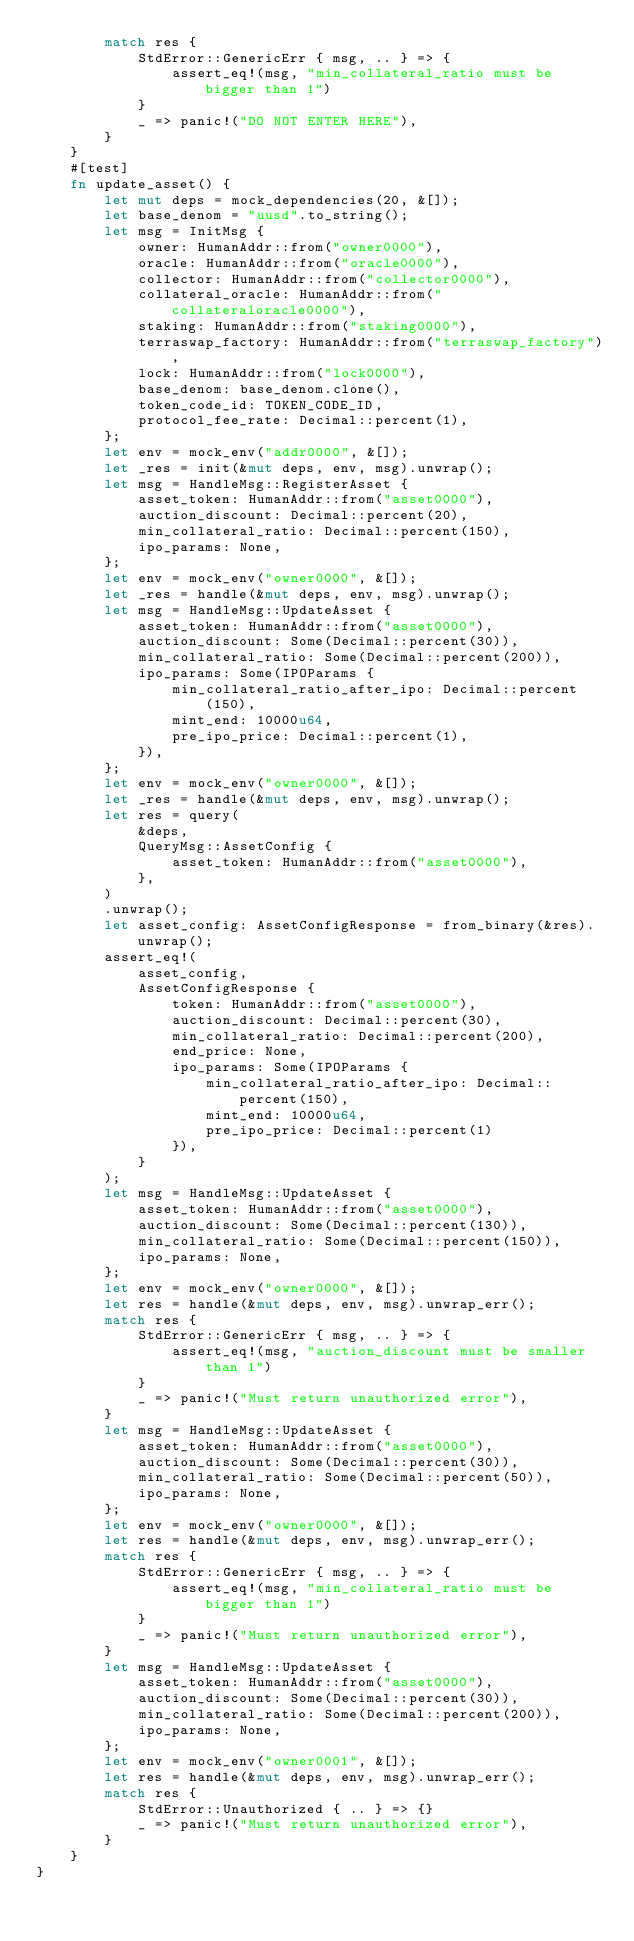<code> <loc_0><loc_0><loc_500><loc_500><_Rust_>        match res {
            StdError::GenericErr { msg, .. } => {
                assert_eq!(msg, "min_collateral_ratio must be bigger than 1")
            }
            _ => panic!("DO NOT ENTER HERE"),
        }
    }
    #[test]
    fn update_asset() {
        let mut deps = mock_dependencies(20, &[]);
        let base_denom = "uusd".to_string();
        let msg = InitMsg {
            owner: HumanAddr::from("owner0000"),
            oracle: HumanAddr::from("oracle0000"),
            collector: HumanAddr::from("collector0000"),
            collateral_oracle: HumanAddr::from("collateraloracle0000"),
            staking: HumanAddr::from("staking0000"),
            terraswap_factory: HumanAddr::from("terraswap_factory"),
            lock: HumanAddr::from("lock0000"),
            base_denom: base_denom.clone(),
            token_code_id: TOKEN_CODE_ID,
            protocol_fee_rate: Decimal::percent(1),
        };
        let env = mock_env("addr0000", &[]);
        let _res = init(&mut deps, env, msg).unwrap();
        let msg = HandleMsg::RegisterAsset {
            asset_token: HumanAddr::from("asset0000"),
            auction_discount: Decimal::percent(20),
            min_collateral_ratio: Decimal::percent(150),
            ipo_params: None,
        };
        let env = mock_env("owner0000", &[]);
        let _res = handle(&mut deps, env, msg).unwrap();
        let msg = HandleMsg::UpdateAsset {
            asset_token: HumanAddr::from("asset0000"),
            auction_discount: Some(Decimal::percent(30)),
            min_collateral_ratio: Some(Decimal::percent(200)),
            ipo_params: Some(IPOParams {
                min_collateral_ratio_after_ipo: Decimal::percent(150),
                mint_end: 10000u64,
                pre_ipo_price: Decimal::percent(1),
            }),
        };
        let env = mock_env("owner0000", &[]);
        let _res = handle(&mut deps, env, msg).unwrap();
        let res = query(
            &deps,
            QueryMsg::AssetConfig {
                asset_token: HumanAddr::from("asset0000"),
            },
        )
        .unwrap();
        let asset_config: AssetConfigResponse = from_binary(&res).unwrap();
        assert_eq!(
            asset_config,
            AssetConfigResponse {
                token: HumanAddr::from("asset0000"),
                auction_discount: Decimal::percent(30),
                min_collateral_ratio: Decimal::percent(200),
                end_price: None,
                ipo_params: Some(IPOParams {
                    min_collateral_ratio_after_ipo: Decimal::percent(150),
                    mint_end: 10000u64,
                    pre_ipo_price: Decimal::percent(1)
                }),
            }
        );
        let msg = HandleMsg::UpdateAsset {
            asset_token: HumanAddr::from("asset0000"),
            auction_discount: Some(Decimal::percent(130)),
            min_collateral_ratio: Some(Decimal::percent(150)),
            ipo_params: None,
        };
        let env = mock_env("owner0000", &[]);
        let res = handle(&mut deps, env, msg).unwrap_err();
        match res {
            StdError::GenericErr { msg, .. } => {
                assert_eq!(msg, "auction_discount must be smaller than 1")
            }
            _ => panic!("Must return unauthorized error"),
        }
        let msg = HandleMsg::UpdateAsset {
            asset_token: HumanAddr::from("asset0000"),
            auction_discount: Some(Decimal::percent(30)),
            min_collateral_ratio: Some(Decimal::percent(50)),
            ipo_params: None,
        };
        let env = mock_env("owner0000", &[]);
        let res = handle(&mut deps, env, msg).unwrap_err();
        match res {
            StdError::GenericErr { msg, .. } => {
                assert_eq!(msg, "min_collateral_ratio must be bigger than 1")
            }
            _ => panic!("Must return unauthorized error"),
        }
        let msg = HandleMsg::UpdateAsset {
            asset_token: HumanAddr::from("asset0000"),
            auction_discount: Some(Decimal::percent(30)),
            min_collateral_ratio: Some(Decimal::percent(200)),
            ipo_params: None,
        };
        let env = mock_env("owner0001", &[]);
        let res = handle(&mut deps, env, msg).unwrap_err();
        match res {
            StdError::Unauthorized { .. } => {}
            _ => panic!("Must return unauthorized error"),
        }
    }
}
</code> 